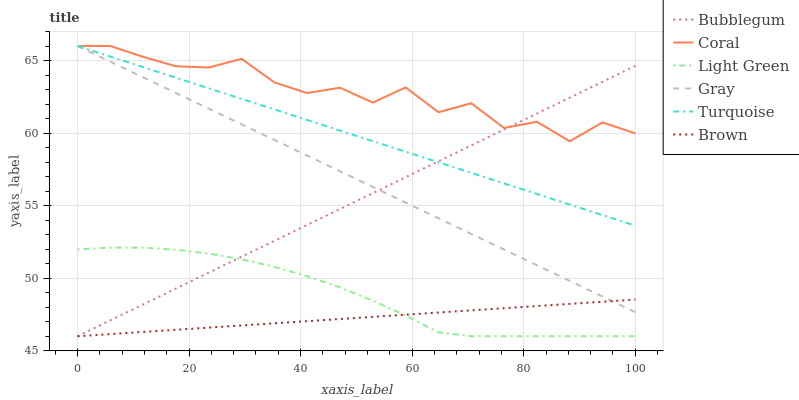Does Brown have the minimum area under the curve?
Answer yes or no. Yes. Does Coral have the maximum area under the curve?
Answer yes or no. Yes. Does Turquoise have the minimum area under the curve?
Answer yes or no. No. Does Turquoise have the maximum area under the curve?
Answer yes or no. No. Is Bubblegum the smoothest?
Answer yes or no. Yes. Is Coral the roughest?
Answer yes or no. Yes. Is Turquoise the smoothest?
Answer yes or no. No. Is Turquoise the roughest?
Answer yes or no. No. Does Brown have the lowest value?
Answer yes or no. Yes. Does Turquoise have the lowest value?
Answer yes or no. No. Does Coral have the highest value?
Answer yes or no. Yes. Does Brown have the highest value?
Answer yes or no. No. Is Light Green less than Coral?
Answer yes or no. Yes. Is Turquoise greater than Light Green?
Answer yes or no. Yes. Does Turquoise intersect Coral?
Answer yes or no. Yes. Is Turquoise less than Coral?
Answer yes or no. No. Is Turquoise greater than Coral?
Answer yes or no. No. Does Light Green intersect Coral?
Answer yes or no. No. 